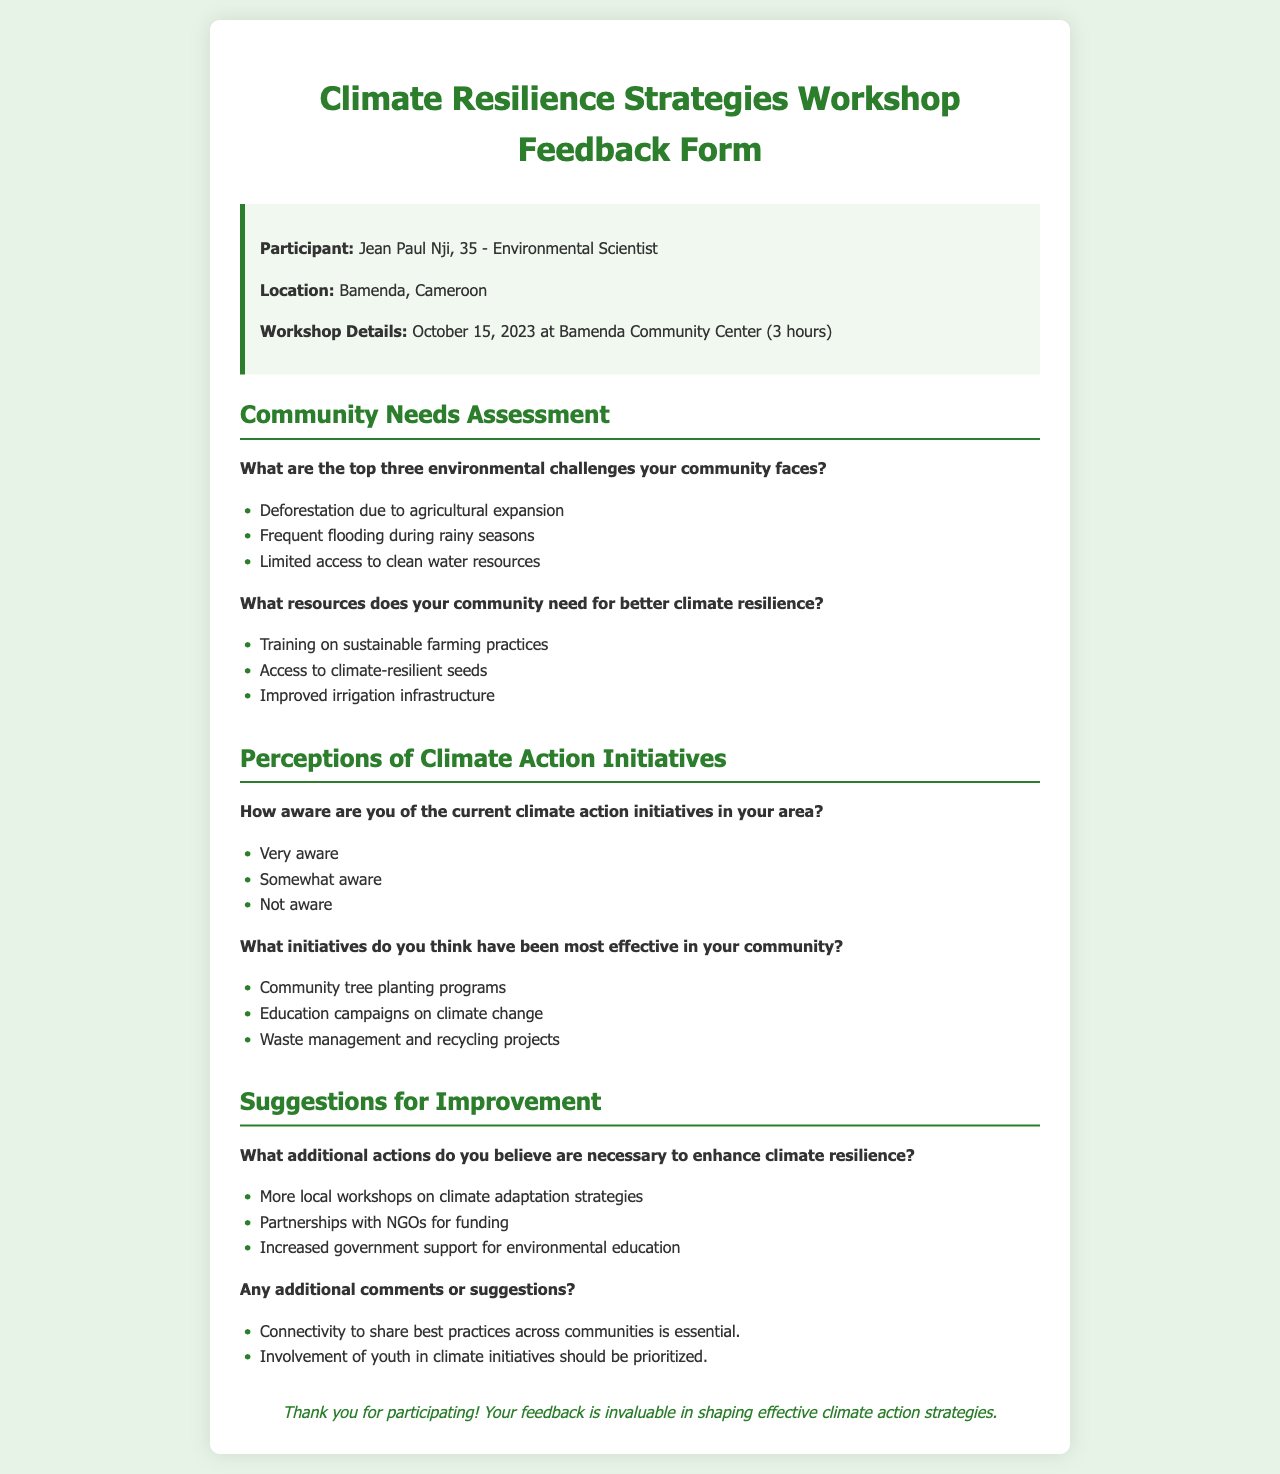What is the name of the participant? The participant's name is mentioned in the info box of the document.
Answer: Jean Paul Nji What is the location of the workshop? The document specifies the location where the workshop took place.
Answer: Bamenda, Cameroon When was the workshop held? The date of the workshop is provided in the workshop details section.
Answer: October 15, 2023 What is one of the top environmental challenges faced by the community? The document lists the community's environmental challenges in the needs assessment section.
Answer: Deforestation due to agricultural expansion What resources does the community need for better climate resilience? The document outlines specific resources needed by the community for climate resilience.
Answer: Training on sustainable farming practices How aware is the participant of current climate action initiatives? The participant's level of awareness regarding climate initiatives is stated in the perceptions section.
Answer: Very aware What has been identified as an effective initiative in the community? The document lists several initiatives deemed effective in the community.
Answer: Community tree planting programs What additional actions does the participant believe are necessary? The document notes the participant's suggestions for enhancing climate resilience.
Answer: More local workshops on climate adaptation strategies What is one comment made by the participant? The additional comments section contains valuable insights from the participant.
Answer: Connectivity to share best practices across communities is essential 